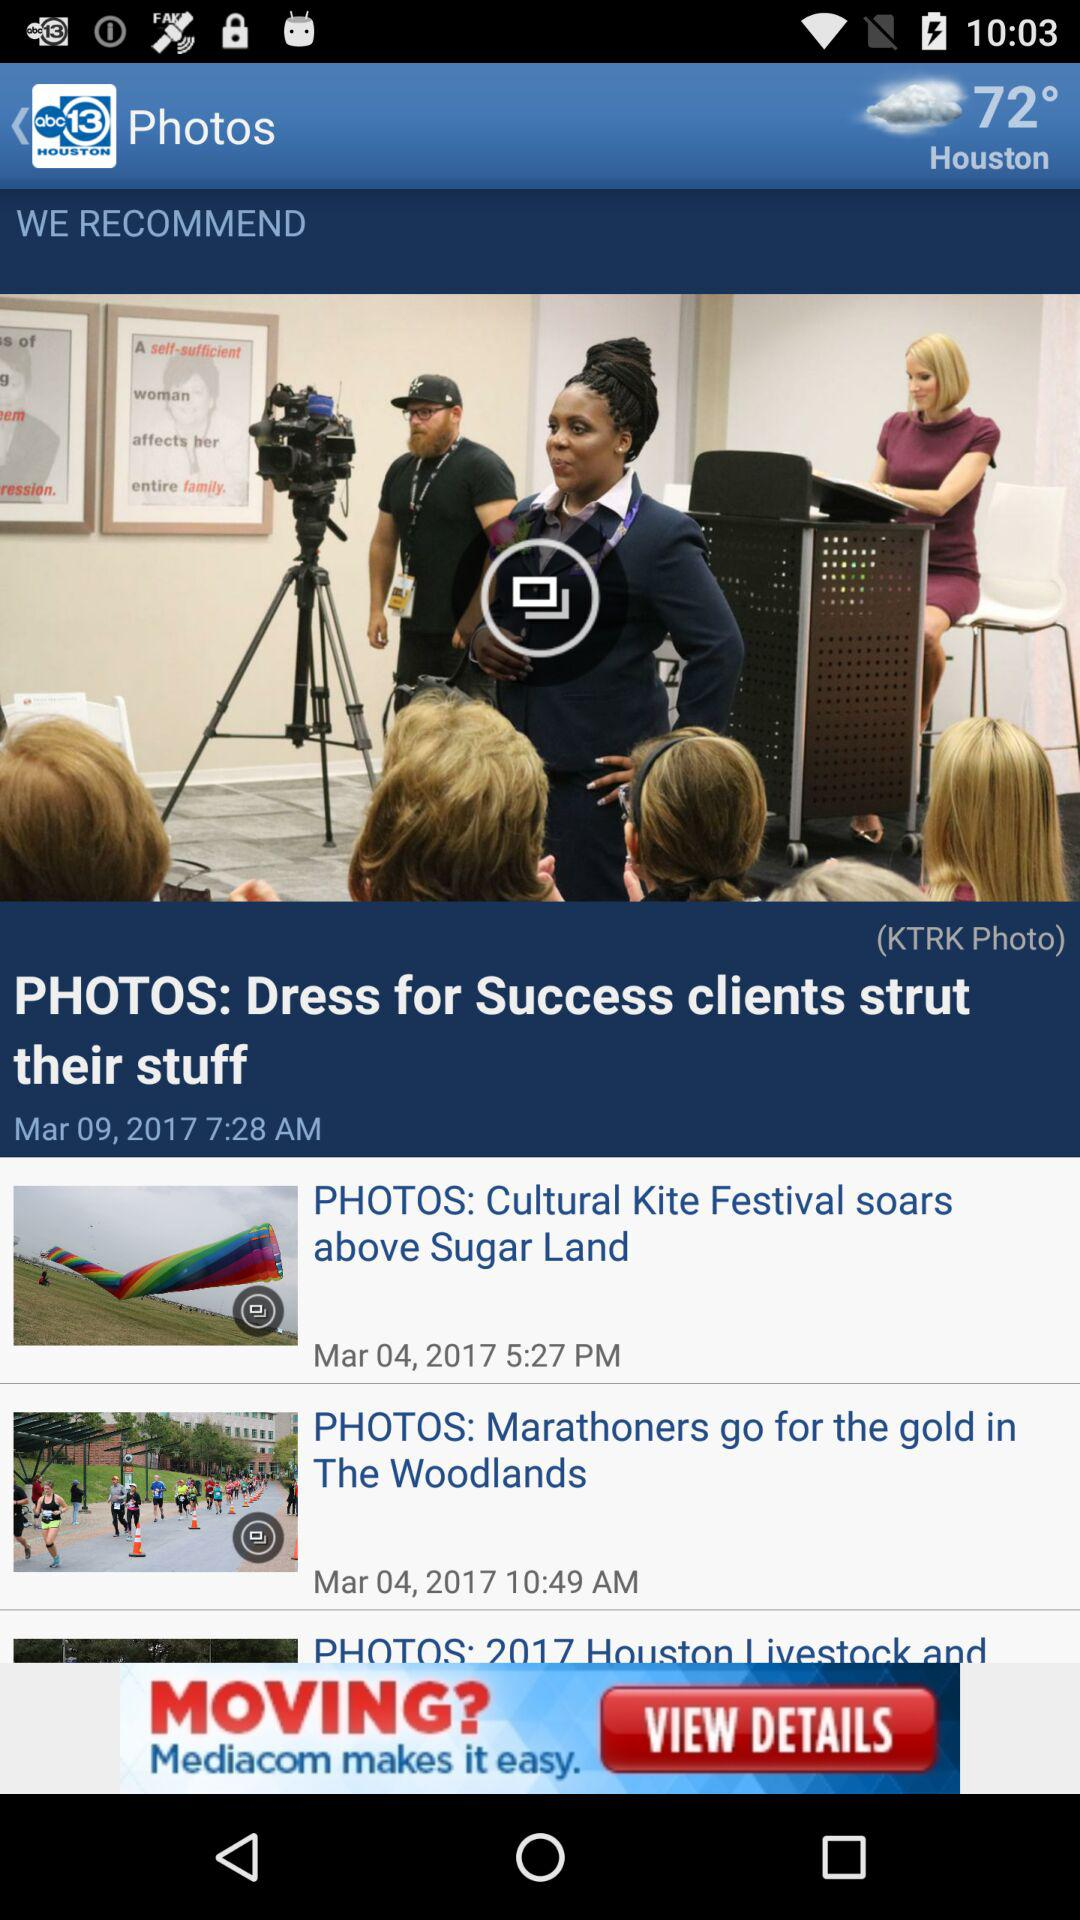What is the post date of "Dress for Success clients strut their stuff"? The post date is March 09, 2017. 